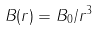Convert formula to latex. <formula><loc_0><loc_0><loc_500><loc_500>B ( r ) = B _ { 0 } / r ^ { 3 }</formula> 